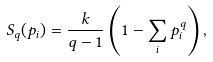<formula> <loc_0><loc_0><loc_500><loc_500>S _ { q } ( { p _ { i } } ) = { \frac { k } { q - 1 } } \left ( 1 - \sum _ { i } p _ { i } ^ { q } \right ) ,</formula> 